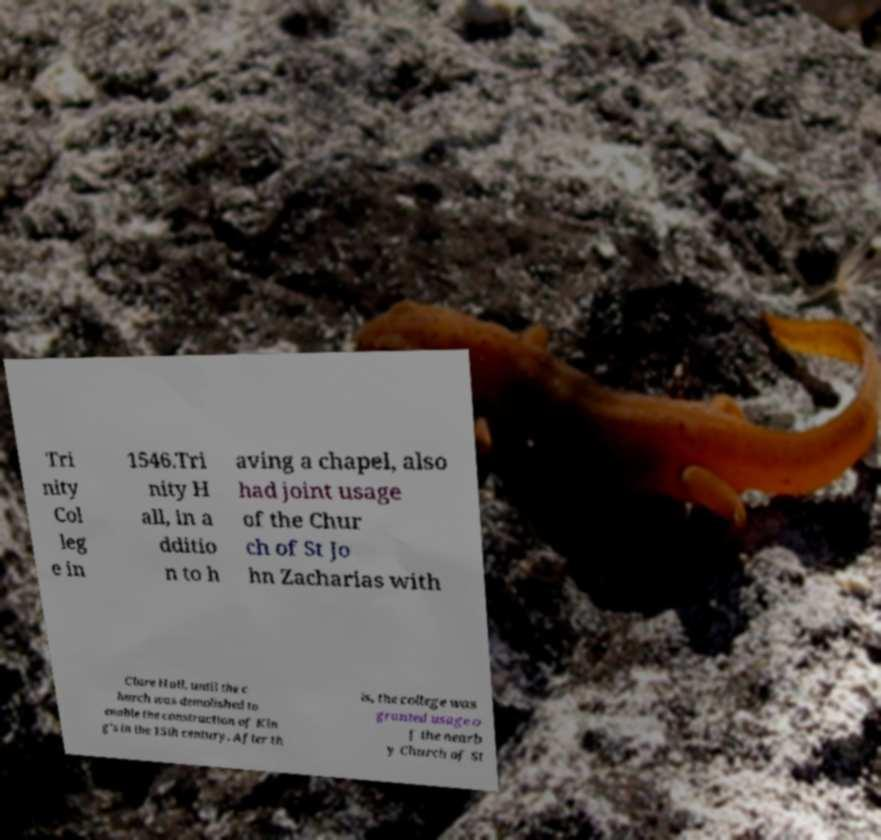Can you read and provide the text displayed in the image?This photo seems to have some interesting text. Can you extract and type it out for me? Tri nity Col leg e in 1546.Tri nity H all, in a dditio n to h aving a chapel, also had joint usage of the Chur ch of St Jo hn Zacharias with Clare Hall, until the c hurch was demolished to enable the construction of Kin g's in the 15th century. After th is, the college was granted usage o f the nearb y Church of St 